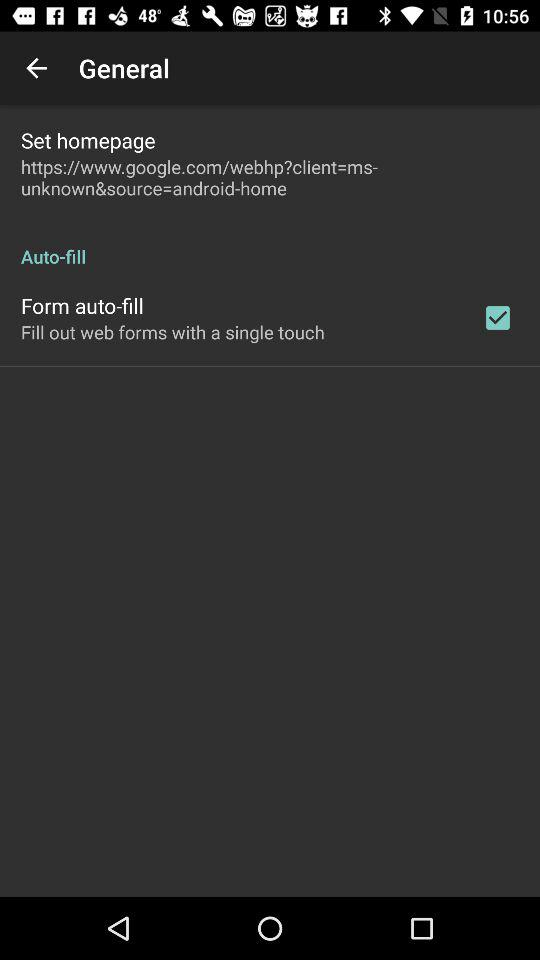How many checkbox elements are there on this screen?
Answer the question using a single word or phrase. 1 